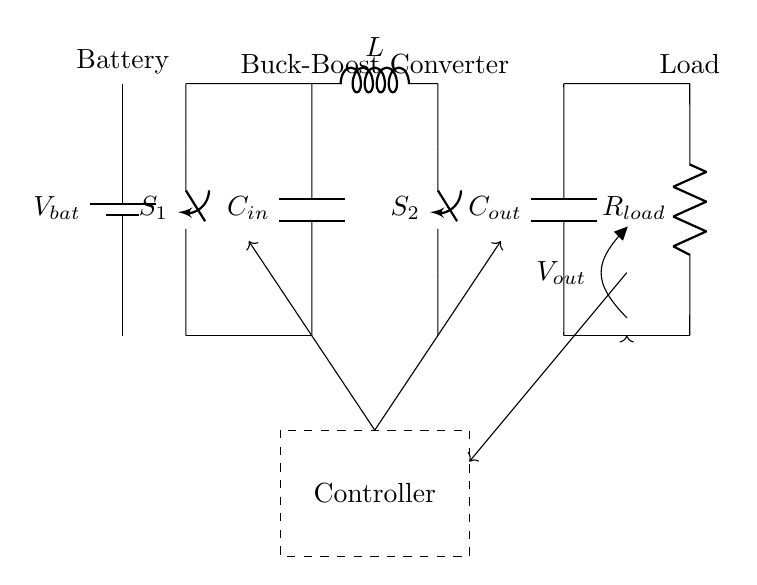What is the battery type in this circuit? The circuit includes a battery symbol marked as V_bat, which typically represents a standard battery in electronic circuits.
Answer: V_bat What component regulates the voltage output? The buck-boost converter is the component that regulates the voltage by stepping it up or down as needed. It is depicted in the circuit directly connected to both the battery and the load.
Answer: Buck-Boost Converter How many switches are present in this circuit? The circuit diagram shows two switches, labeled S1 and S2, which control the operation of the circuit.
Answer: 2 What is the function of the inductor in this circuit? The inductor here is part of the buck-boost converter's operation, where it stores energy when current flows through. Inductors in this circuit are crucial for energy conversion and maintaining efficient operation.
Answer: Energy storage What role does the controller play in this circuit? The controller manages the operation of the buck-boost converter, ensuring that the output voltage remains stable under varying load conditions. It interprets the voltage levels and issues commands to switch elements on and off.
Answer: Regulation What is the relationship between C_in and C_out in this circuit? Capacitors C_in and C_out serve different purposes: C_in filters input voltage to the buck-boost converter, while C_out smooths the output voltage supplied to the load. Both are essential for maintaining voltage stability.
Answer: Smoothing and filtering 